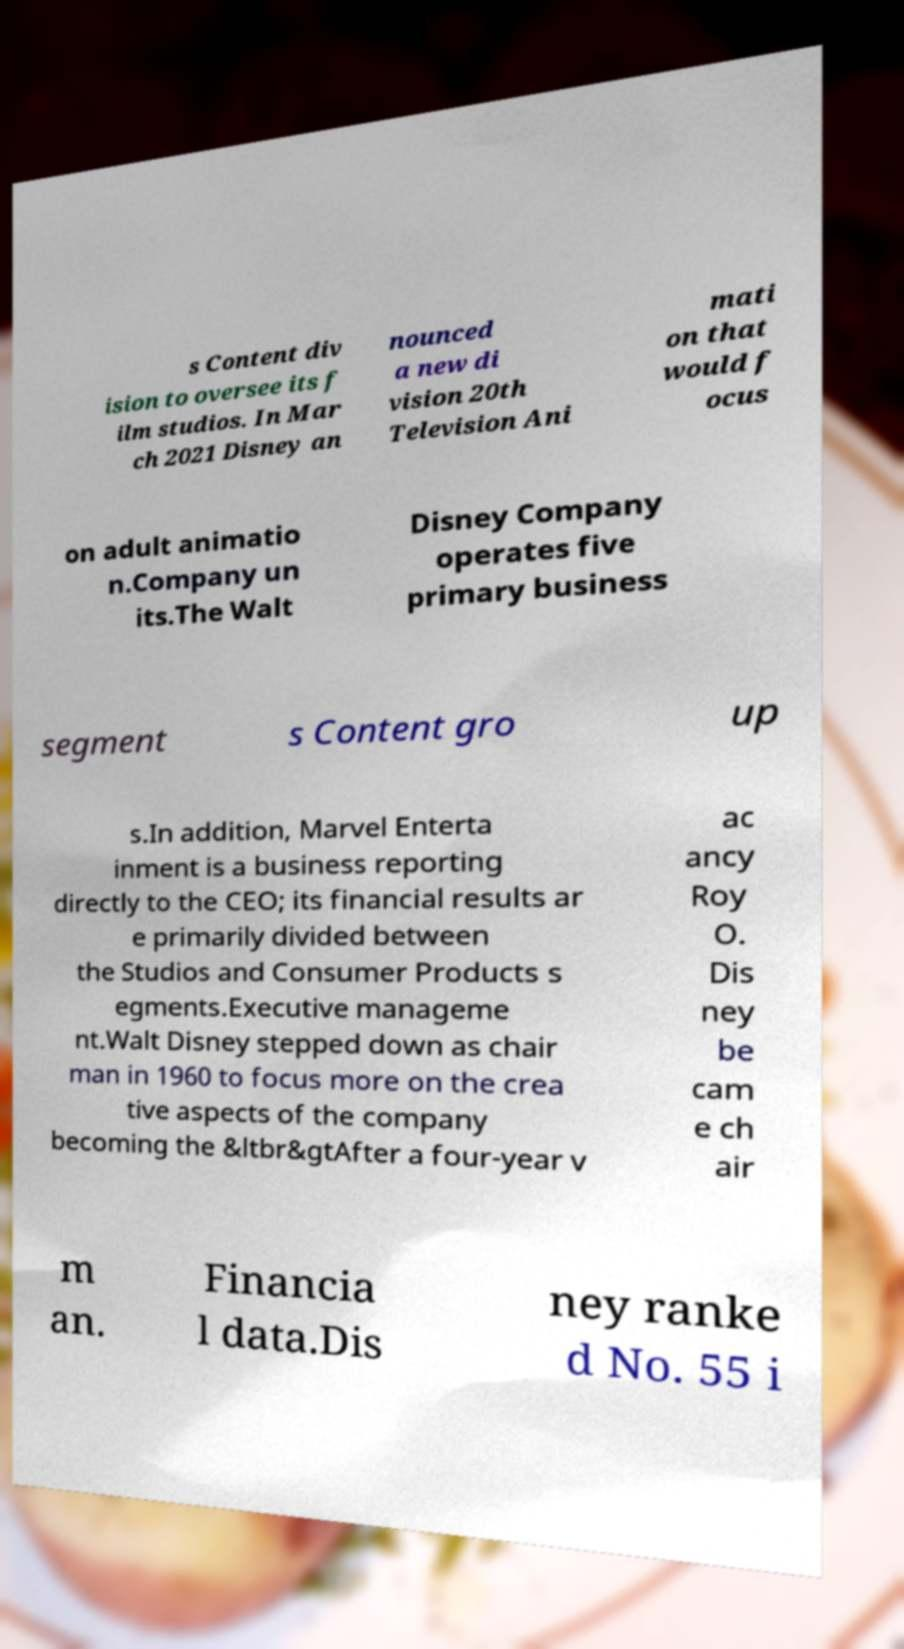There's text embedded in this image that I need extracted. Can you transcribe it verbatim? s Content div ision to oversee its f ilm studios. In Mar ch 2021 Disney an nounced a new di vision 20th Television Ani mati on that would f ocus on adult animatio n.Company un its.The Walt Disney Company operates five primary business segment s Content gro up s.In addition, Marvel Enterta inment is a business reporting directly to the CEO; its financial results ar e primarily divided between the Studios and Consumer Products s egments.Executive manageme nt.Walt Disney stepped down as chair man in 1960 to focus more on the crea tive aspects of the company becoming the &ltbr&gtAfter a four-year v ac ancy Roy O. Dis ney be cam e ch air m an. Financia l data.Dis ney ranke d No. 55 i 